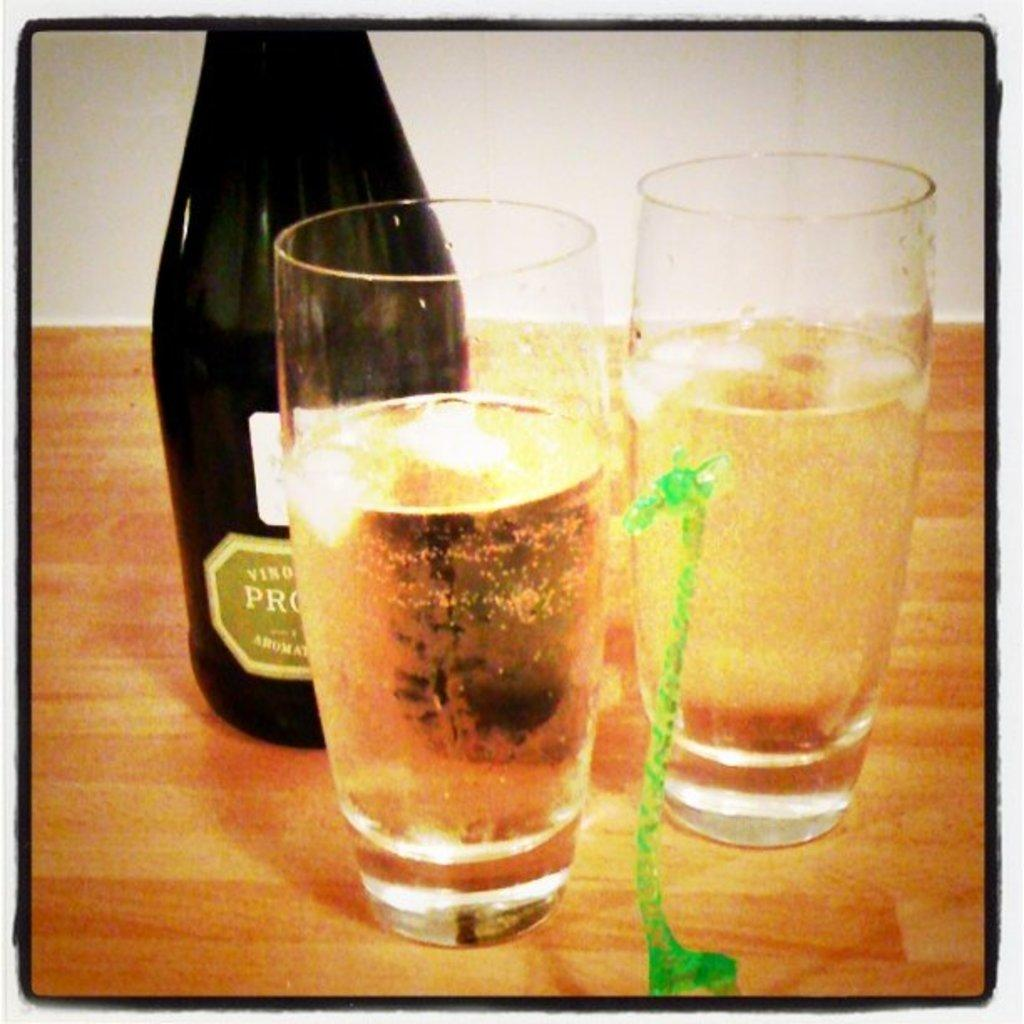What is present in the image that can hold liquids? There is a bottle and glasses in the image that can hold liquids. What is inside the glasses? The glasses contain drinks. What color is the object in the image? There is a green object in the image. What can be found on the bottle? There is writing on the bottle. Can you tell me how many beads are on the swing in the image? There is no swing or beads present in the image. What type of pencil can be seen being used to write on the bottle? There is no pencil visible in the image; the writing on the bottle is likely printed or handwritten with a pen or marker. 